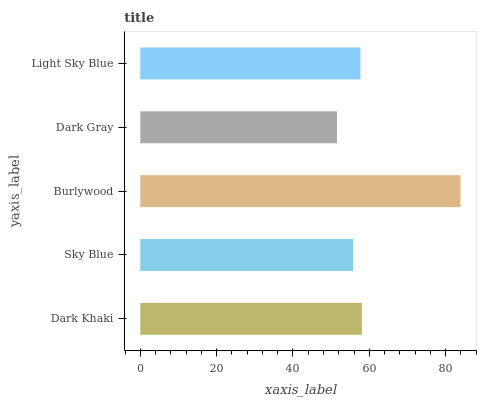Is Dark Gray the minimum?
Answer yes or no. Yes. Is Burlywood the maximum?
Answer yes or no. Yes. Is Sky Blue the minimum?
Answer yes or no. No. Is Sky Blue the maximum?
Answer yes or no. No. Is Dark Khaki greater than Sky Blue?
Answer yes or no. Yes. Is Sky Blue less than Dark Khaki?
Answer yes or no. Yes. Is Sky Blue greater than Dark Khaki?
Answer yes or no. No. Is Dark Khaki less than Sky Blue?
Answer yes or no. No. Is Light Sky Blue the high median?
Answer yes or no. Yes. Is Light Sky Blue the low median?
Answer yes or no. Yes. Is Dark Gray the high median?
Answer yes or no. No. Is Dark Khaki the low median?
Answer yes or no. No. 